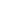<formula> <loc_0><loc_0><loc_500><loc_500>& \\ & \\ &</formula> 